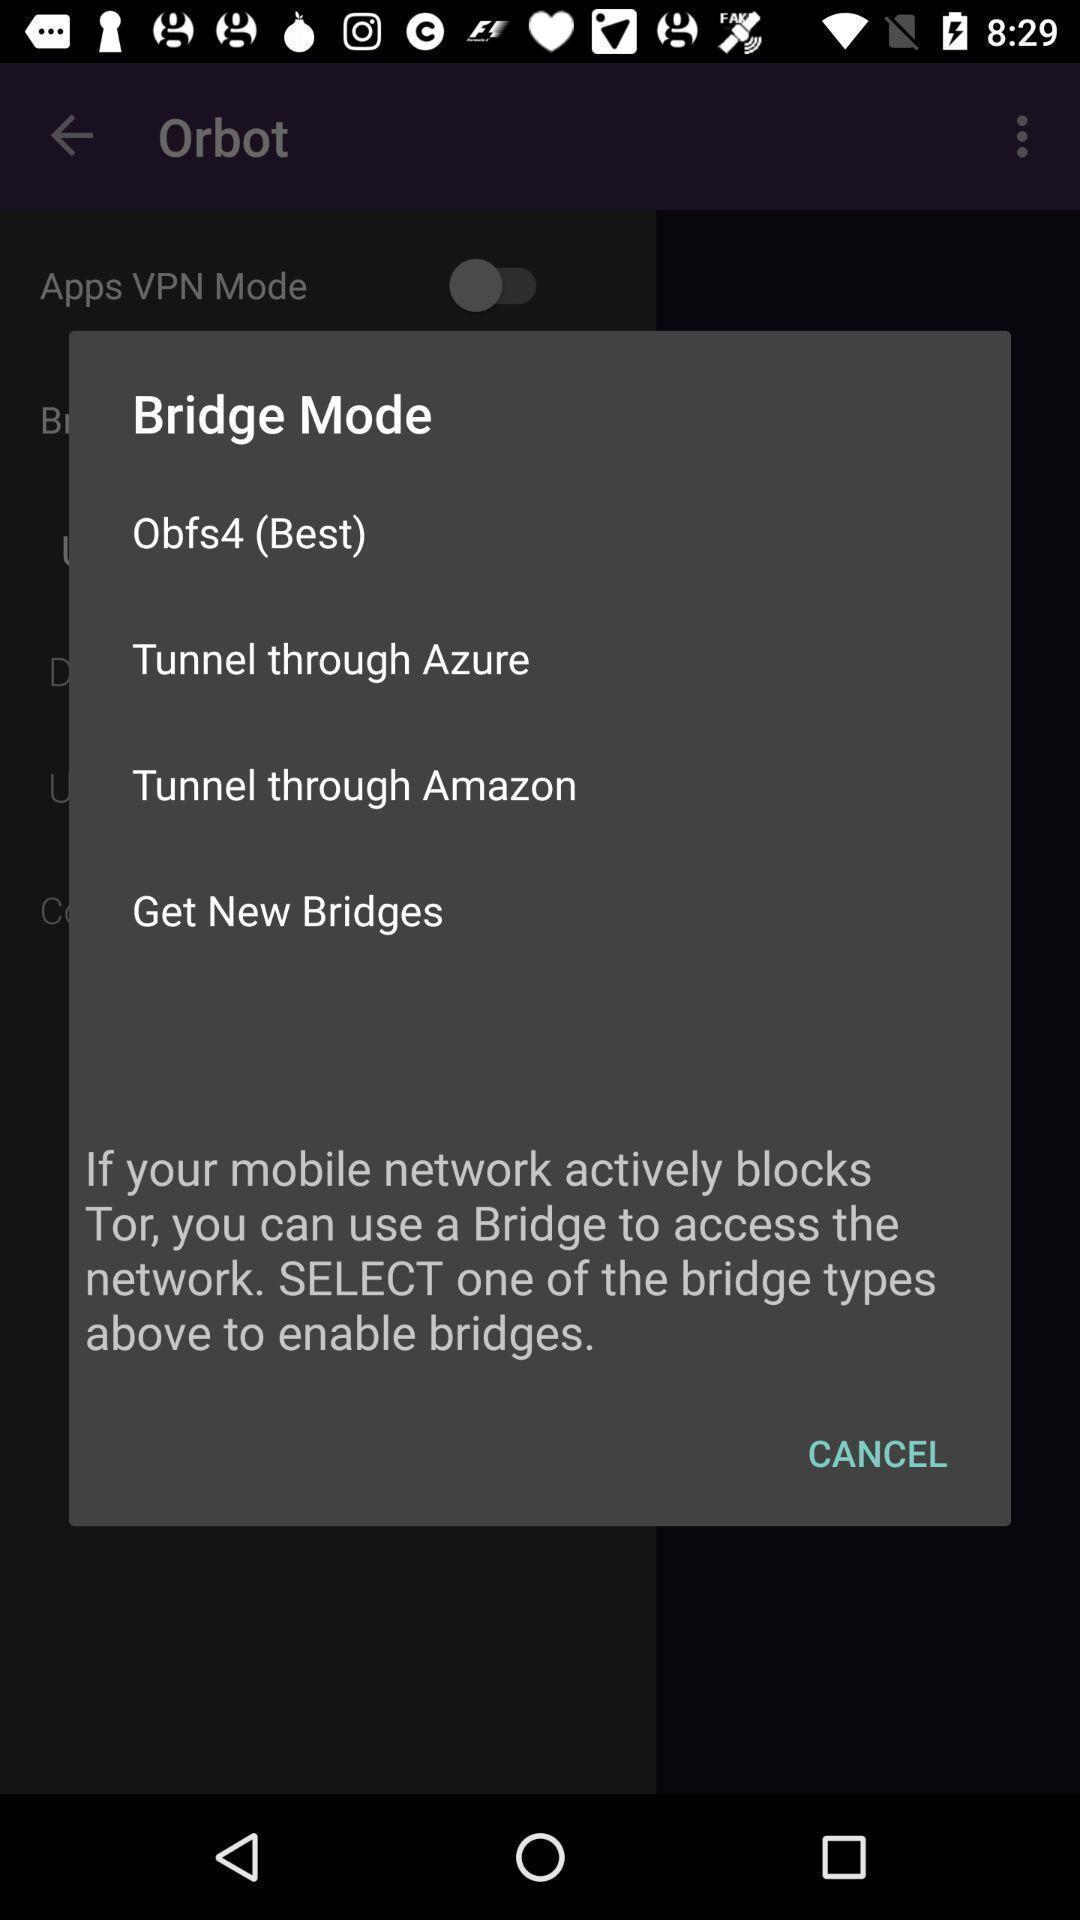Explain what's happening in this screen capture. Pop-up is giving information about bridge types. 